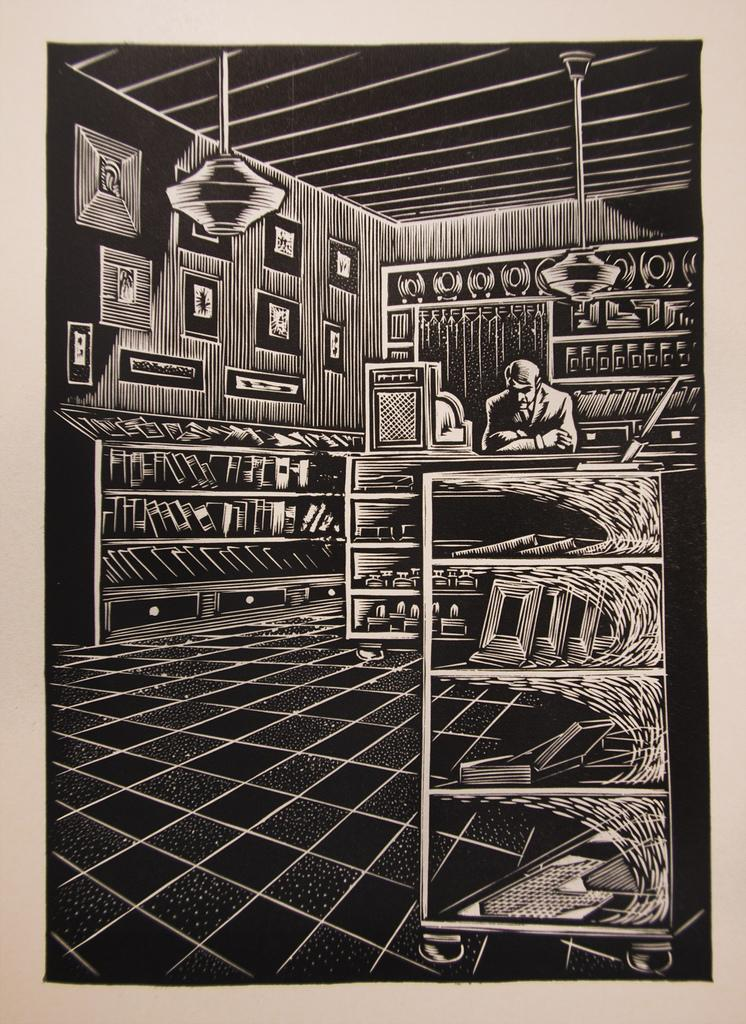<image>
Write a terse but informative summary of the picture. A sketch of a man in behind the counter in a bookshop has no text in the drawing. 